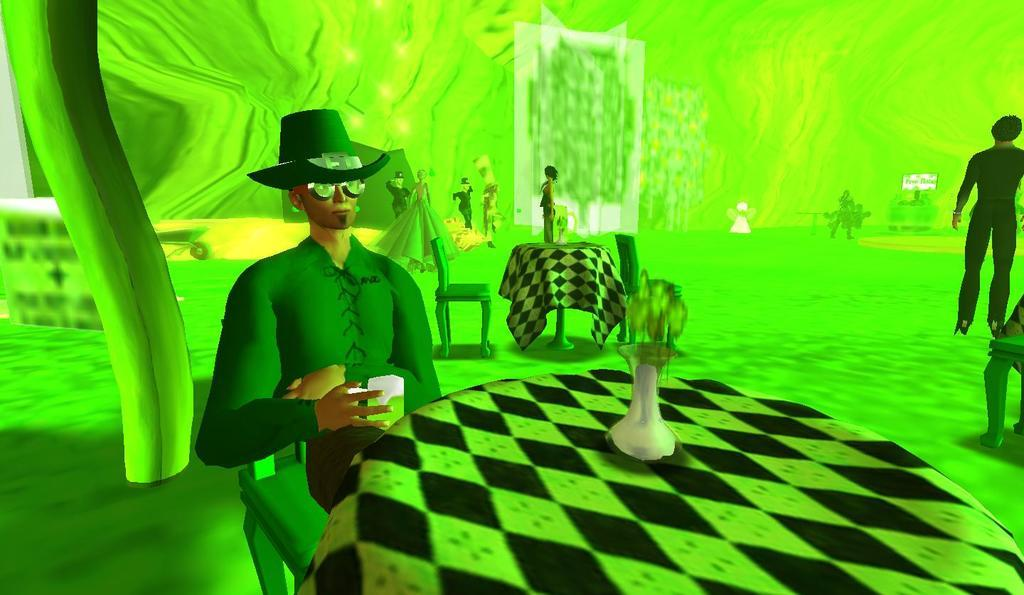What is the man in the image doing? The man is sitting in the image. What is the man holding in the image? The man is holding a cup. What type of furniture is present in the image? There are chairs in the image. What can be seen on the tables in the image? There are objects on tables in the image. How many people are in the image? There are people in the image. What color is the background of the image? The background of the image is green. What type of alley can be seen in the image? There is no alley present in the image. What type of plough is being used by the man in the image? There is no plough present in the image; the man is holding a cup. 